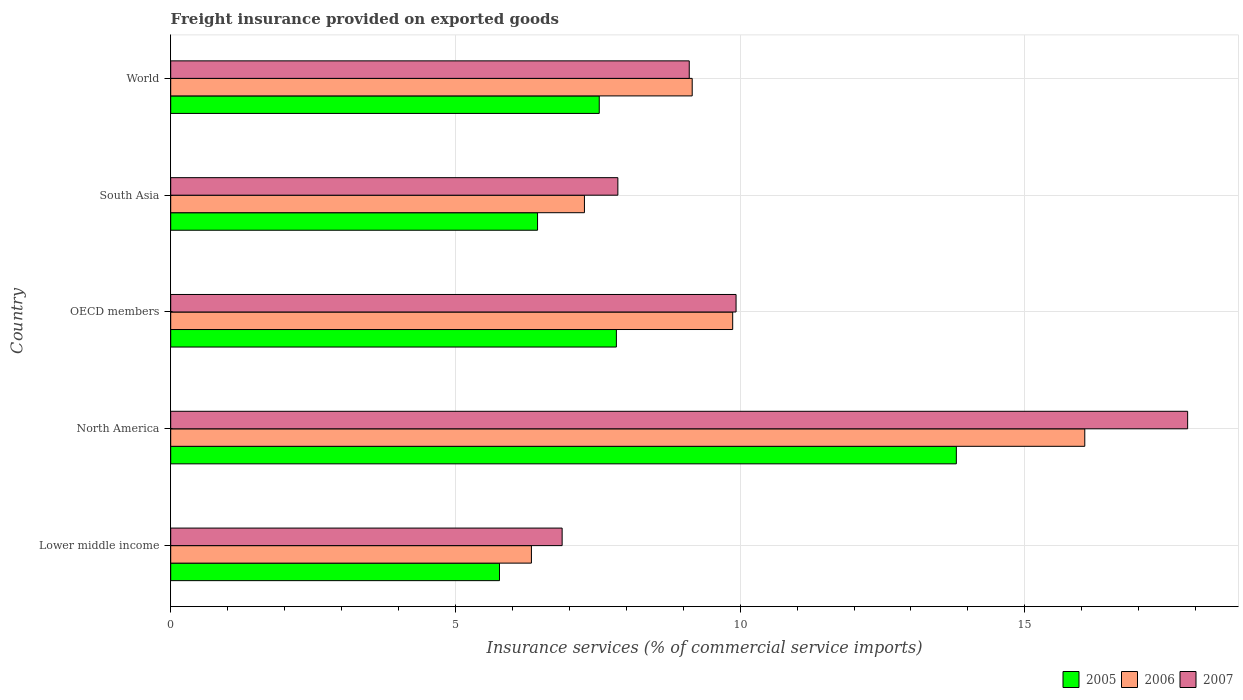How many different coloured bars are there?
Provide a succinct answer. 3. Are the number of bars on each tick of the Y-axis equal?
Offer a very short reply. Yes. How many bars are there on the 5th tick from the top?
Offer a very short reply. 3. How many bars are there on the 3rd tick from the bottom?
Your answer should be very brief. 3. What is the label of the 2nd group of bars from the top?
Make the answer very short. South Asia. What is the freight insurance provided on exported goods in 2007 in OECD members?
Your response must be concise. 9.93. Across all countries, what is the maximum freight insurance provided on exported goods in 2005?
Make the answer very short. 13.8. Across all countries, what is the minimum freight insurance provided on exported goods in 2007?
Ensure brevity in your answer.  6.87. In which country was the freight insurance provided on exported goods in 2005 maximum?
Your response must be concise. North America. In which country was the freight insurance provided on exported goods in 2005 minimum?
Provide a short and direct response. Lower middle income. What is the total freight insurance provided on exported goods in 2007 in the graph?
Provide a succinct answer. 51.62. What is the difference between the freight insurance provided on exported goods in 2007 in North America and that in South Asia?
Your response must be concise. 10.01. What is the difference between the freight insurance provided on exported goods in 2007 in South Asia and the freight insurance provided on exported goods in 2005 in OECD members?
Offer a very short reply. 0.03. What is the average freight insurance provided on exported goods in 2006 per country?
Offer a very short reply. 9.74. What is the difference between the freight insurance provided on exported goods in 2005 and freight insurance provided on exported goods in 2006 in Lower middle income?
Provide a short and direct response. -0.56. In how many countries, is the freight insurance provided on exported goods in 2006 greater than 1 %?
Provide a succinct answer. 5. What is the ratio of the freight insurance provided on exported goods in 2005 in North America to that in World?
Offer a terse response. 1.83. Is the difference between the freight insurance provided on exported goods in 2005 in Lower middle income and North America greater than the difference between the freight insurance provided on exported goods in 2006 in Lower middle income and North America?
Your response must be concise. Yes. What is the difference between the highest and the second highest freight insurance provided on exported goods in 2007?
Provide a succinct answer. 7.93. What is the difference between the highest and the lowest freight insurance provided on exported goods in 2006?
Provide a short and direct response. 9.72. What does the 2nd bar from the top in World represents?
Ensure brevity in your answer.  2006. Is it the case that in every country, the sum of the freight insurance provided on exported goods in 2007 and freight insurance provided on exported goods in 2006 is greater than the freight insurance provided on exported goods in 2005?
Make the answer very short. Yes. Are all the bars in the graph horizontal?
Provide a succinct answer. Yes. Does the graph contain any zero values?
Your answer should be very brief. No. Does the graph contain grids?
Offer a very short reply. Yes. Where does the legend appear in the graph?
Provide a succinct answer. Bottom right. What is the title of the graph?
Ensure brevity in your answer.  Freight insurance provided on exported goods. What is the label or title of the X-axis?
Ensure brevity in your answer.  Insurance services (% of commercial service imports). What is the label or title of the Y-axis?
Offer a very short reply. Country. What is the Insurance services (% of commercial service imports) of 2005 in Lower middle income?
Give a very brief answer. 5.77. What is the Insurance services (% of commercial service imports) in 2006 in Lower middle income?
Provide a succinct answer. 6.33. What is the Insurance services (% of commercial service imports) of 2007 in Lower middle income?
Your answer should be very brief. 6.87. What is the Insurance services (% of commercial service imports) in 2005 in North America?
Your answer should be very brief. 13.8. What is the Insurance services (% of commercial service imports) of 2006 in North America?
Make the answer very short. 16.05. What is the Insurance services (% of commercial service imports) in 2007 in North America?
Your answer should be very brief. 17.86. What is the Insurance services (% of commercial service imports) of 2005 in OECD members?
Your answer should be compact. 7.83. What is the Insurance services (% of commercial service imports) of 2006 in OECD members?
Offer a very short reply. 9.87. What is the Insurance services (% of commercial service imports) in 2007 in OECD members?
Make the answer very short. 9.93. What is the Insurance services (% of commercial service imports) in 2005 in South Asia?
Offer a terse response. 6.44. What is the Insurance services (% of commercial service imports) of 2006 in South Asia?
Ensure brevity in your answer.  7.27. What is the Insurance services (% of commercial service imports) in 2007 in South Asia?
Your answer should be compact. 7.85. What is the Insurance services (% of commercial service imports) in 2005 in World?
Keep it short and to the point. 7.53. What is the Insurance services (% of commercial service imports) of 2006 in World?
Your answer should be compact. 9.16. What is the Insurance services (% of commercial service imports) of 2007 in World?
Make the answer very short. 9.11. Across all countries, what is the maximum Insurance services (% of commercial service imports) of 2005?
Make the answer very short. 13.8. Across all countries, what is the maximum Insurance services (% of commercial service imports) in 2006?
Ensure brevity in your answer.  16.05. Across all countries, what is the maximum Insurance services (% of commercial service imports) in 2007?
Provide a short and direct response. 17.86. Across all countries, what is the minimum Insurance services (% of commercial service imports) of 2005?
Offer a very short reply. 5.77. Across all countries, what is the minimum Insurance services (% of commercial service imports) of 2006?
Your answer should be compact. 6.33. Across all countries, what is the minimum Insurance services (% of commercial service imports) in 2007?
Your answer should be very brief. 6.87. What is the total Insurance services (% of commercial service imports) in 2005 in the graph?
Give a very brief answer. 41.36. What is the total Insurance services (% of commercial service imports) in 2006 in the graph?
Make the answer very short. 48.68. What is the total Insurance services (% of commercial service imports) in 2007 in the graph?
Provide a short and direct response. 51.62. What is the difference between the Insurance services (% of commercial service imports) of 2005 in Lower middle income and that in North America?
Your response must be concise. -8.02. What is the difference between the Insurance services (% of commercial service imports) of 2006 in Lower middle income and that in North America?
Keep it short and to the point. -9.72. What is the difference between the Insurance services (% of commercial service imports) of 2007 in Lower middle income and that in North America?
Provide a short and direct response. -10.98. What is the difference between the Insurance services (% of commercial service imports) in 2005 in Lower middle income and that in OECD members?
Your response must be concise. -2.05. What is the difference between the Insurance services (% of commercial service imports) of 2006 in Lower middle income and that in OECD members?
Your answer should be very brief. -3.53. What is the difference between the Insurance services (% of commercial service imports) of 2007 in Lower middle income and that in OECD members?
Your response must be concise. -3.05. What is the difference between the Insurance services (% of commercial service imports) of 2005 in Lower middle income and that in South Asia?
Give a very brief answer. -0.67. What is the difference between the Insurance services (% of commercial service imports) of 2006 in Lower middle income and that in South Asia?
Keep it short and to the point. -0.93. What is the difference between the Insurance services (% of commercial service imports) of 2007 in Lower middle income and that in South Asia?
Provide a succinct answer. -0.98. What is the difference between the Insurance services (% of commercial service imports) in 2005 in Lower middle income and that in World?
Keep it short and to the point. -1.75. What is the difference between the Insurance services (% of commercial service imports) in 2006 in Lower middle income and that in World?
Offer a terse response. -2.82. What is the difference between the Insurance services (% of commercial service imports) of 2007 in Lower middle income and that in World?
Make the answer very short. -2.23. What is the difference between the Insurance services (% of commercial service imports) in 2005 in North America and that in OECD members?
Your answer should be compact. 5.97. What is the difference between the Insurance services (% of commercial service imports) in 2006 in North America and that in OECD members?
Ensure brevity in your answer.  6.18. What is the difference between the Insurance services (% of commercial service imports) of 2007 in North America and that in OECD members?
Ensure brevity in your answer.  7.93. What is the difference between the Insurance services (% of commercial service imports) of 2005 in North America and that in South Asia?
Offer a terse response. 7.35. What is the difference between the Insurance services (% of commercial service imports) of 2006 in North America and that in South Asia?
Give a very brief answer. 8.79. What is the difference between the Insurance services (% of commercial service imports) in 2007 in North America and that in South Asia?
Provide a short and direct response. 10.01. What is the difference between the Insurance services (% of commercial service imports) of 2005 in North America and that in World?
Ensure brevity in your answer.  6.27. What is the difference between the Insurance services (% of commercial service imports) of 2006 in North America and that in World?
Your answer should be very brief. 6.89. What is the difference between the Insurance services (% of commercial service imports) in 2007 in North America and that in World?
Offer a terse response. 8.75. What is the difference between the Insurance services (% of commercial service imports) of 2005 in OECD members and that in South Asia?
Your answer should be very brief. 1.38. What is the difference between the Insurance services (% of commercial service imports) of 2006 in OECD members and that in South Asia?
Give a very brief answer. 2.6. What is the difference between the Insurance services (% of commercial service imports) of 2007 in OECD members and that in South Asia?
Your answer should be compact. 2.08. What is the difference between the Insurance services (% of commercial service imports) in 2005 in OECD members and that in World?
Offer a very short reply. 0.3. What is the difference between the Insurance services (% of commercial service imports) in 2006 in OECD members and that in World?
Make the answer very short. 0.71. What is the difference between the Insurance services (% of commercial service imports) of 2007 in OECD members and that in World?
Ensure brevity in your answer.  0.82. What is the difference between the Insurance services (% of commercial service imports) in 2005 in South Asia and that in World?
Keep it short and to the point. -1.08. What is the difference between the Insurance services (% of commercial service imports) of 2006 in South Asia and that in World?
Give a very brief answer. -1.89. What is the difference between the Insurance services (% of commercial service imports) in 2007 in South Asia and that in World?
Ensure brevity in your answer.  -1.25. What is the difference between the Insurance services (% of commercial service imports) of 2005 in Lower middle income and the Insurance services (% of commercial service imports) of 2006 in North America?
Provide a short and direct response. -10.28. What is the difference between the Insurance services (% of commercial service imports) of 2005 in Lower middle income and the Insurance services (% of commercial service imports) of 2007 in North America?
Your response must be concise. -12.08. What is the difference between the Insurance services (% of commercial service imports) in 2006 in Lower middle income and the Insurance services (% of commercial service imports) in 2007 in North America?
Your answer should be compact. -11.52. What is the difference between the Insurance services (% of commercial service imports) of 2005 in Lower middle income and the Insurance services (% of commercial service imports) of 2006 in OECD members?
Give a very brief answer. -4.1. What is the difference between the Insurance services (% of commercial service imports) in 2005 in Lower middle income and the Insurance services (% of commercial service imports) in 2007 in OECD members?
Your response must be concise. -4.15. What is the difference between the Insurance services (% of commercial service imports) in 2006 in Lower middle income and the Insurance services (% of commercial service imports) in 2007 in OECD members?
Ensure brevity in your answer.  -3.59. What is the difference between the Insurance services (% of commercial service imports) of 2005 in Lower middle income and the Insurance services (% of commercial service imports) of 2006 in South Asia?
Provide a succinct answer. -1.49. What is the difference between the Insurance services (% of commercial service imports) of 2005 in Lower middle income and the Insurance services (% of commercial service imports) of 2007 in South Asia?
Your response must be concise. -2.08. What is the difference between the Insurance services (% of commercial service imports) in 2006 in Lower middle income and the Insurance services (% of commercial service imports) in 2007 in South Asia?
Ensure brevity in your answer.  -1.52. What is the difference between the Insurance services (% of commercial service imports) in 2005 in Lower middle income and the Insurance services (% of commercial service imports) in 2006 in World?
Provide a short and direct response. -3.38. What is the difference between the Insurance services (% of commercial service imports) of 2005 in Lower middle income and the Insurance services (% of commercial service imports) of 2007 in World?
Offer a very short reply. -3.33. What is the difference between the Insurance services (% of commercial service imports) of 2006 in Lower middle income and the Insurance services (% of commercial service imports) of 2007 in World?
Your answer should be compact. -2.77. What is the difference between the Insurance services (% of commercial service imports) in 2005 in North America and the Insurance services (% of commercial service imports) in 2006 in OECD members?
Keep it short and to the point. 3.93. What is the difference between the Insurance services (% of commercial service imports) of 2005 in North America and the Insurance services (% of commercial service imports) of 2007 in OECD members?
Offer a terse response. 3.87. What is the difference between the Insurance services (% of commercial service imports) in 2006 in North America and the Insurance services (% of commercial service imports) in 2007 in OECD members?
Provide a succinct answer. 6.12. What is the difference between the Insurance services (% of commercial service imports) in 2005 in North America and the Insurance services (% of commercial service imports) in 2006 in South Asia?
Keep it short and to the point. 6.53. What is the difference between the Insurance services (% of commercial service imports) of 2005 in North America and the Insurance services (% of commercial service imports) of 2007 in South Asia?
Provide a succinct answer. 5.94. What is the difference between the Insurance services (% of commercial service imports) of 2006 in North America and the Insurance services (% of commercial service imports) of 2007 in South Asia?
Offer a terse response. 8.2. What is the difference between the Insurance services (% of commercial service imports) in 2005 in North America and the Insurance services (% of commercial service imports) in 2006 in World?
Ensure brevity in your answer.  4.64. What is the difference between the Insurance services (% of commercial service imports) in 2005 in North America and the Insurance services (% of commercial service imports) in 2007 in World?
Give a very brief answer. 4.69. What is the difference between the Insurance services (% of commercial service imports) in 2006 in North America and the Insurance services (% of commercial service imports) in 2007 in World?
Your answer should be very brief. 6.95. What is the difference between the Insurance services (% of commercial service imports) of 2005 in OECD members and the Insurance services (% of commercial service imports) of 2006 in South Asia?
Ensure brevity in your answer.  0.56. What is the difference between the Insurance services (% of commercial service imports) in 2005 in OECD members and the Insurance services (% of commercial service imports) in 2007 in South Asia?
Make the answer very short. -0.03. What is the difference between the Insurance services (% of commercial service imports) in 2006 in OECD members and the Insurance services (% of commercial service imports) in 2007 in South Asia?
Give a very brief answer. 2.02. What is the difference between the Insurance services (% of commercial service imports) in 2005 in OECD members and the Insurance services (% of commercial service imports) in 2006 in World?
Offer a terse response. -1.33. What is the difference between the Insurance services (% of commercial service imports) in 2005 in OECD members and the Insurance services (% of commercial service imports) in 2007 in World?
Your answer should be very brief. -1.28. What is the difference between the Insurance services (% of commercial service imports) of 2006 in OECD members and the Insurance services (% of commercial service imports) of 2007 in World?
Provide a short and direct response. 0.76. What is the difference between the Insurance services (% of commercial service imports) of 2005 in South Asia and the Insurance services (% of commercial service imports) of 2006 in World?
Your response must be concise. -2.72. What is the difference between the Insurance services (% of commercial service imports) of 2005 in South Asia and the Insurance services (% of commercial service imports) of 2007 in World?
Your answer should be compact. -2.66. What is the difference between the Insurance services (% of commercial service imports) in 2006 in South Asia and the Insurance services (% of commercial service imports) in 2007 in World?
Your answer should be compact. -1.84. What is the average Insurance services (% of commercial service imports) of 2005 per country?
Your response must be concise. 8.27. What is the average Insurance services (% of commercial service imports) in 2006 per country?
Ensure brevity in your answer.  9.74. What is the average Insurance services (% of commercial service imports) in 2007 per country?
Ensure brevity in your answer.  10.32. What is the difference between the Insurance services (% of commercial service imports) of 2005 and Insurance services (% of commercial service imports) of 2006 in Lower middle income?
Keep it short and to the point. -0.56. What is the difference between the Insurance services (% of commercial service imports) in 2005 and Insurance services (% of commercial service imports) in 2007 in Lower middle income?
Provide a succinct answer. -1.1. What is the difference between the Insurance services (% of commercial service imports) of 2006 and Insurance services (% of commercial service imports) of 2007 in Lower middle income?
Provide a short and direct response. -0.54. What is the difference between the Insurance services (% of commercial service imports) in 2005 and Insurance services (% of commercial service imports) in 2006 in North America?
Provide a succinct answer. -2.26. What is the difference between the Insurance services (% of commercial service imports) in 2005 and Insurance services (% of commercial service imports) in 2007 in North America?
Your response must be concise. -4.06. What is the difference between the Insurance services (% of commercial service imports) of 2006 and Insurance services (% of commercial service imports) of 2007 in North America?
Your answer should be very brief. -1.81. What is the difference between the Insurance services (% of commercial service imports) of 2005 and Insurance services (% of commercial service imports) of 2006 in OECD members?
Offer a terse response. -2.04. What is the difference between the Insurance services (% of commercial service imports) of 2005 and Insurance services (% of commercial service imports) of 2007 in OECD members?
Offer a terse response. -2.1. What is the difference between the Insurance services (% of commercial service imports) of 2006 and Insurance services (% of commercial service imports) of 2007 in OECD members?
Your answer should be very brief. -0.06. What is the difference between the Insurance services (% of commercial service imports) of 2005 and Insurance services (% of commercial service imports) of 2006 in South Asia?
Give a very brief answer. -0.82. What is the difference between the Insurance services (% of commercial service imports) in 2005 and Insurance services (% of commercial service imports) in 2007 in South Asia?
Offer a very short reply. -1.41. What is the difference between the Insurance services (% of commercial service imports) of 2006 and Insurance services (% of commercial service imports) of 2007 in South Asia?
Offer a very short reply. -0.59. What is the difference between the Insurance services (% of commercial service imports) of 2005 and Insurance services (% of commercial service imports) of 2006 in World?
Your answer should be very brief. -1.63. What is the difference between the Insurance services (% of commercial service imports) of 2005 and Insurance services (% of commercial service imports) of 2007 in World?
Keep it short and to the point. -1.58. What is the difference between the Insurance services (% of commercial service imports) in 2006 and Insurance services (% of commercial service imports) in 2007 in World?
Offer a terse response. 0.05. What is the ratio of the Insurance services (% of commercial service imports) of 2005 in Lower middle income to that in North America?
Offer a very short reply. 0.42. What is the ratio of the Insurance services (% of commercial service imports) in 2006 in Lower middle income to that in North America?
Ensure brevity in your answer.  0.39. What is the ratio of the Insurance services (% of commercial service imports) in 2007 in Lower middle income to that in North America?
Ensure brevity in your answer.  0.38. What is the ratio of the Insurance services (% of commercial service imports) in 2005 in Lower middle income to that in OECD members?
Offer a very short reply. 0.74. What is the ratio of the Insurance services (% of commercial service imports) of 2006 in Lower middle income to that in OECD members?
Make the answer very short. 0.64. What is the ratio of the Insurance services (% of commercial service imports) of 2007 in Lower middle income to that in OECD members?
Keep it short and to the point. 0.69. What is the ratio of the Insurance services (% of commercial service imports) of 2005 in Lower middle income to that in South Asia?
Your answer should be very brief. 0.9. What is the ratio of the Insurance services (% of commercial service imports) in 2006 in Lower middle income to that in South Asia?
Your answer should be very brief. 0.87. What is the ratio of the Insurance services (% of commercial service imports) of 2007 in Lower middle income to that in South Asia?
Provide a short and direct response. 0.88. What is the ratio of the Insurance services (% of commercial service imports) in 2005 in Lower middle income to that in World?
Offer a very short reply. 0.77. What is the ratio of the Insurance services (% of commercial service imports) of 2006 in Lower middle income to that in World?
Provide a succinct answer. 0.69. What is the ratio of the Insurance services (% of commercial service imports) of 2007 in Lower middle income to that in World?
Your response must be concise. 0.75. What is the ratio of the Insurance services (% of commercial service imports) in 2005 in North America to that in OECD members?
Provide a short and direct response. 1.76. What is the ratio of the Insurance services (% of commercial service imports) in 2006 in North America to that in OECD members?
Offer a terse response. 1.63. What is the ratio of the Insurance services (% of commercial service imports) of 2007 in North America to that in OECD members?
Make the answer very short. 1.8. What is the ratio of the Insurance services (% of commercial service imports) in 2005 in North America to that in South Asia?
Your response must be concise. 2.14. What is the ratio of the Insurance services (% of commercial service imports) of 2006 in North America to that in South Asia?
Give a very brief answer. 2.21. What is the ratio of the Insurance services (% of commercial service imports) in 2007 in North America to that in South Asia?
Offer a terse response. 2.27. What is the ratio of the Insurance services (% of commercial service imports) in 2005 in North America to that in World?
Provide a succinct answer. 1.83. What is the ratio of the Insurance services (% of commercial service imports) of 2006 in North America to that in World?
Ensure brevity in your answer.  1.75. What is the ratio of the Insurance services (% of commercial service imports) of 2007 in North America to that in World?
Your response must be concise. 1.96. What is the ratio of the Insurance services (% of commercial service imports) of 2005 in OECD members to that in South Asia?
Ensure brevity in your answer.  1.21. What is the ratio of the Insurance services (% of commercial service imports) in 2006 in OECD members to that in South Asia?
Give a very brief answer. 1.36. What is the ratio of the Insurance services (% of commercial service imports) of 2007 in OECD members to that in South Asia?
Your response must be concise. 1.26. What is the ratio of the Insurance services (% of commercial service imports) of 2006 in OECD members to that in World?
Give a very brief answer. 1.08. What is the ratio of the Insurance services (% of commercial service imports) in 2007 in OECD members to that in World?
Give a very brief answer. 1.09. What is the ratio of the Insurance services (% of commercial service imports) in 2005 in South Asia to that in World?
Ensure brevity in your answer.  0.86. What is the ratio of the Insurance services (% of commercial service imports) of 2006 in South Asia to that in World?
Provide a short and direct response. 0.79. What is the ratio of the Insurance services (% of commercial service imports) of 2007 in South Asia to that in World?
Your answer should be compact. 0.86. What is the difference between the highest and the second highest Insurance services (% of commercial service imports) in 2005?
Give a very brief answer. 5.97. What is the difference between the highest and the second highest Insurance services (% of commercial service imports) of 2006?
Your answer should be very brief. 6.18. What is the difference between the highest and the second highest Insurance services (% of commercial service imports) of 2007?
Keep it short and to the point. 7.93. What is the difference between the highest and the lowest Insurance services (% of commercial service imports) in 2005?
Give a very brief answer. 8.02. What is the difference between the highest and the lowest Insurance services (% of commercial service imports) in 2006?
Provide a short and direct response. 9.72. What is the difference between the highest and the lowest Insurance services (% of commercial service imports) in 2007?
Offer a terse response. 10.98. 